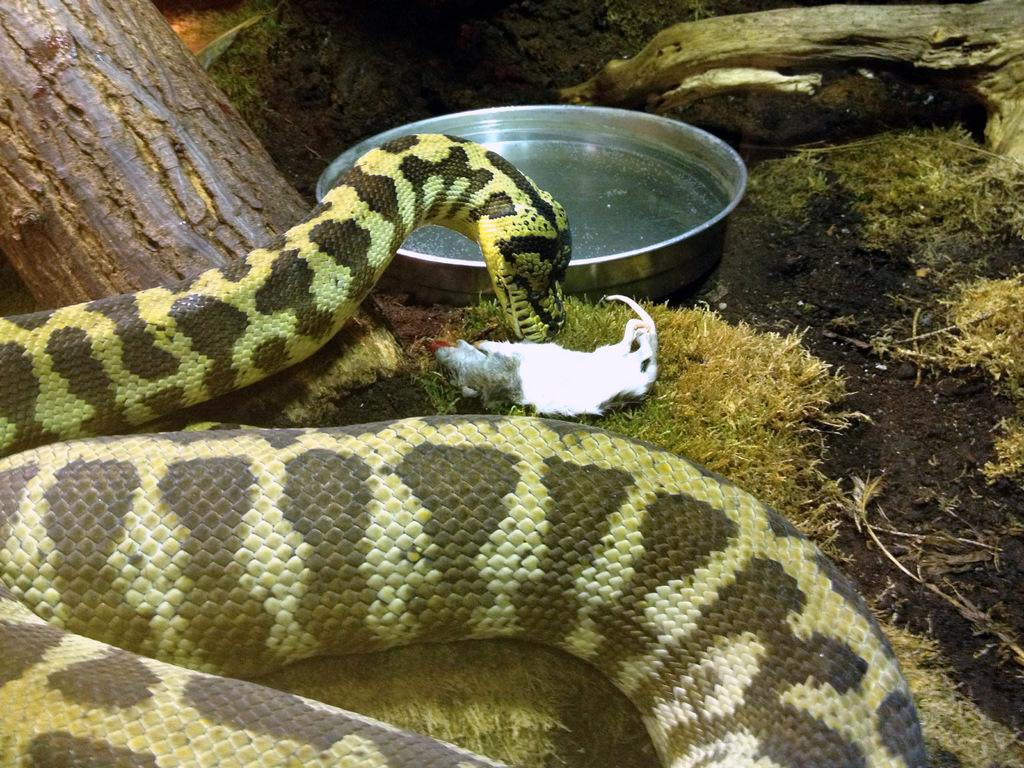What animal can be seen in the image? There is a snake in the image. What is the snake doing in the image? The snake is eating on the surface of the grass. Is there any source of hydration for the snake in the image? Yes, there is a plate with water in front of the snake. What can be seen in the background of the image? There is a tree beside the snake. What type of education is being provided to the crowd in the image? There is no crowd present in the image, and therefore no education is being provided. 